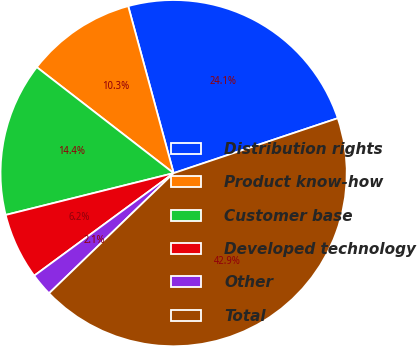Convert chart. <chart><loc_0><loc_0><loc_500><loc_500><pie_chart><fcel>Distribution rights<fcel>Product know-how<fcel>Customer base<fcel>Developed technology<fcel>Other<fcel>Total<nl><fcel>24.09%<fcel>10.29%<fcel>14.37%<fcel>6.21%<fcel>2.12%<fcel>42.93%<nl></chart> 